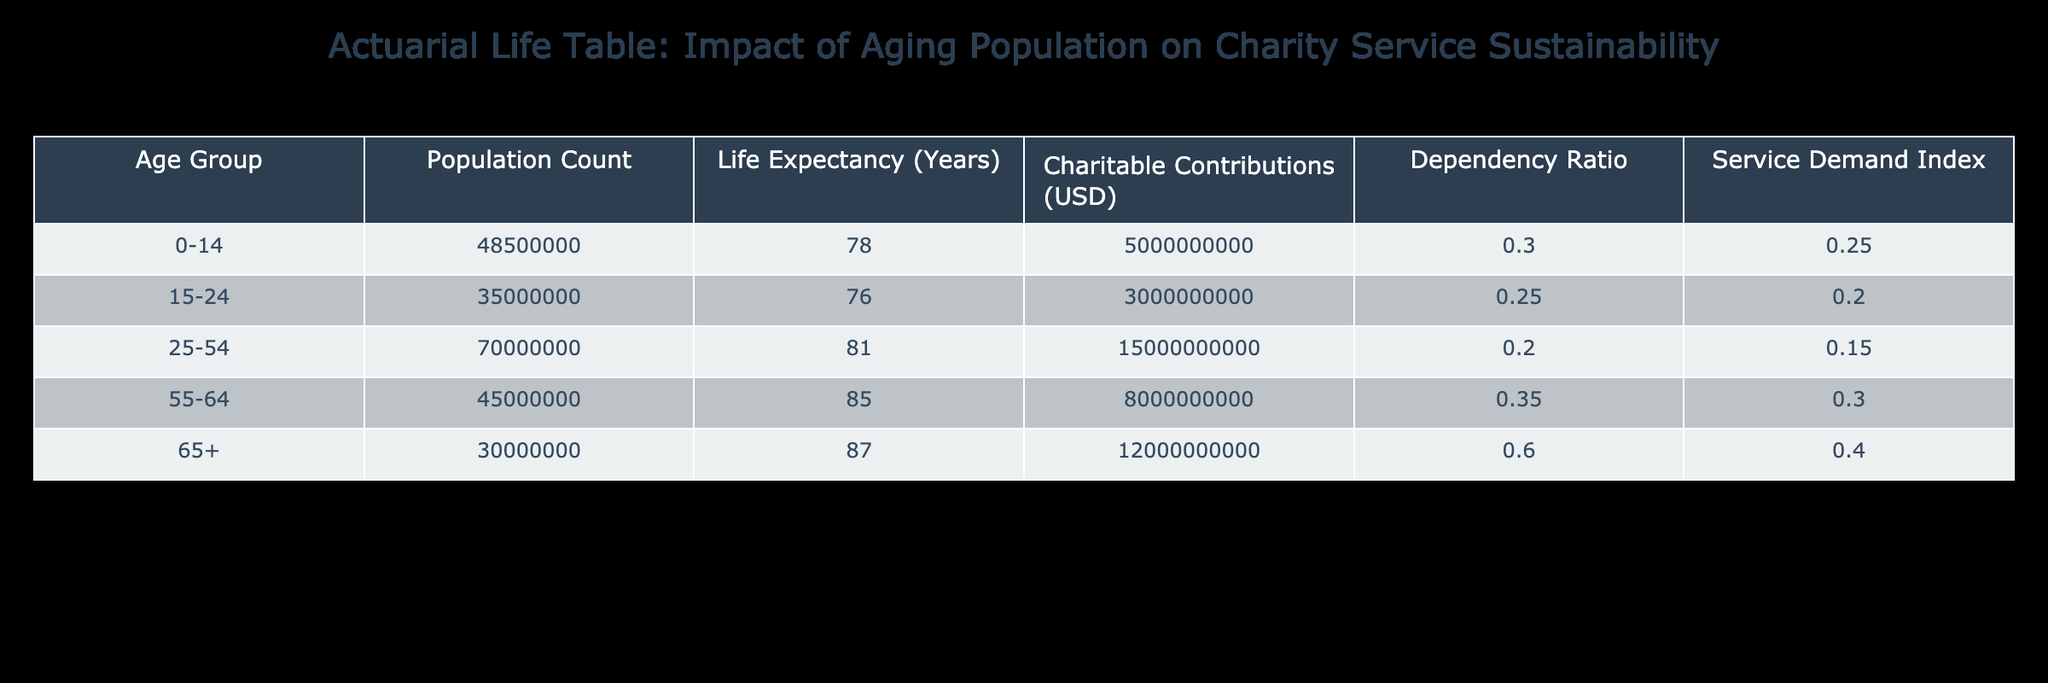What is the population count of the age group 25-54? The table shows the specific population count for each age group. For the age group 25-54, the corresponding value in the "Population Count" column is 70,000,000.
Answer: 70,000,000 What is the life expectancy of the age group 65+? By referring to the "Life Expectancy" column for the age group 65+, the value is provided as 87 years.
Answer: 87 Which age group has the highest dependency ratio? The dependency ratio can be found in the column labeled "Dependency Ratio." Comparing values, the age group 65+ has the highest ratio at 0.60.
Answer: 65+ What is the total charitable contributions for the age group 55-64? The "Charitable Contributions" column shows that for the age group 55-64, the total is 8,000,000,000 USD.
Answer: 8,000,000,000 If we calculate the average life expectancy of the age groups 0-14, 15-24, and 25-54, what result do we get? Summing the life expectancies of the specified age groups: 78 (0-14) + 76 (15-24) + 81 (25-54) = 235 years. Then divide by 3 (the number of groups), which gives 235 / 3 = approximately 78.33.
Answer: 78.33 Is the service demand index for the age group 0-14 greater than that for the age group 15-24? By comparing the "Service Demand Index" values, 0.25 (for 0-14) is indeed greater than 0.20 (for 15-24). Therefore, the statement is true.
Answer: Yes What is the total population across all age groups according to the table? Adding the population counts: 48,500,000 (0-14) + 35,000,000 (15-24) + 70,000,000 (25-54) + 45,000,000 (55-64) + 30,000,000 (65+) gives a total of 228,500,000.
Answer: 228,500,000 Does the charitable contribution increase as the age group increases? Analyzing the values in the "Charitable Contributions" column, they are: 5,000,000,000 (0-14), 3,000,000,000 (15-24), 15,000,000,000 (25-54), 8,000,000,000 (55-64), and 12,000,000,000 (65+). The values do not consistently increase as the age group gets older, so the statement is false.
Answer: No Which age group contributes the least in charitable contributions? By reviewing the "Charitable Contributions" column, the age group 15-24 has the lowest contribution amount at 3,000,000,000 USD.
Answer: 15-24 What is the difference in the service demand index between the age groups 55-64 and 65+? The "Service Demand Index" for 55-64 is 0.30 and for 65+ is 0.40. The difference is calculated as 0.40 - 0.30 = 0.10.
Answer: 0.10 